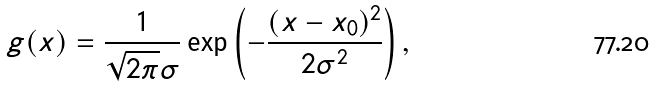<formula> <loc_0><loc_0><loc_500><loc_500>g ( x ) = \frac { 1 } { \sqrt { 2 \pi } \sigma } \exp \left ( - \frac { ( x - x _ { 0 } ) ^ { 2 } } { 2 \sigma ^ { 2 } } \right ) ,</formula> 